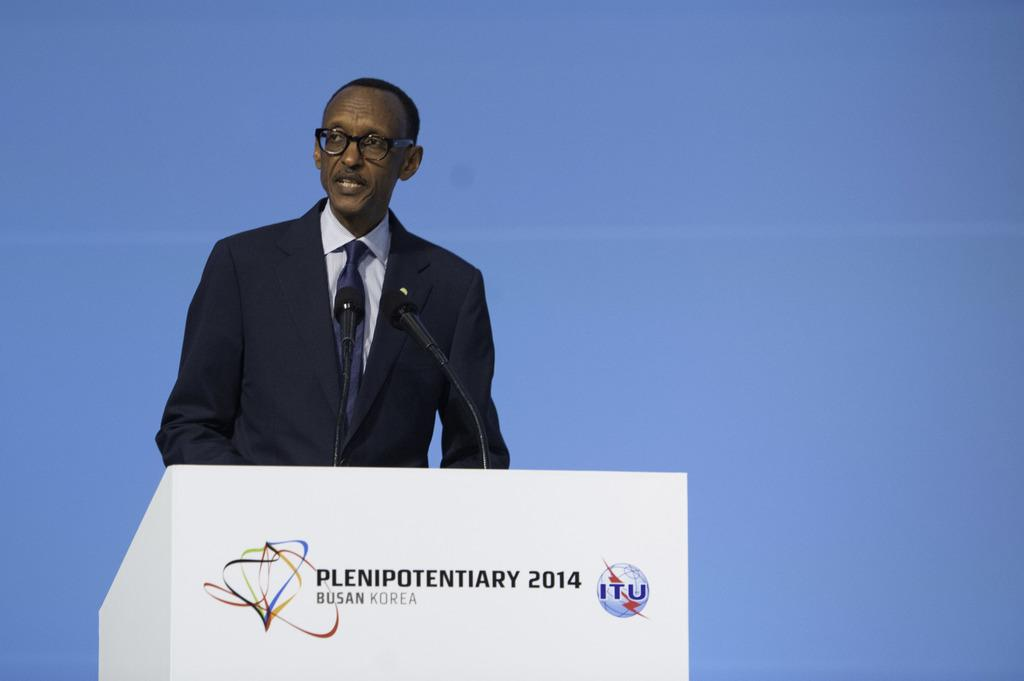What is the main subject of the image? There is a person in the image. What is the person wearing? The person is wearing a black suit and glasses. What is the person standing in front of? The person is standing in front of a podium. How many microphones are visible in the image? There are two microphones visible. What is the color of the background in the image? The background is a plain blue color. How many cakes are being served on the line in the image? There are no cakes or lines present in the image; it features a person standing in front of a podium with two microphones. What type of milk is being poured into the glasses in the image? There are no glasses or milk present in the image; it features a person standing in front of a podium with two microphones. 